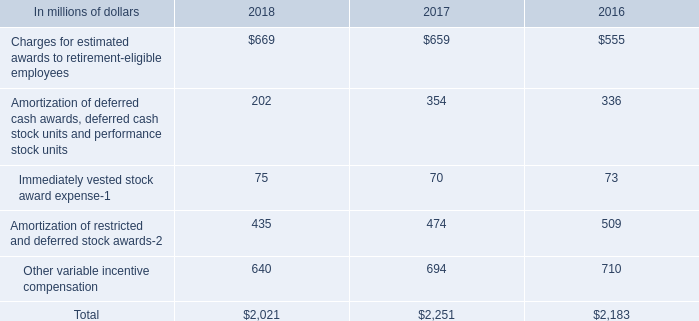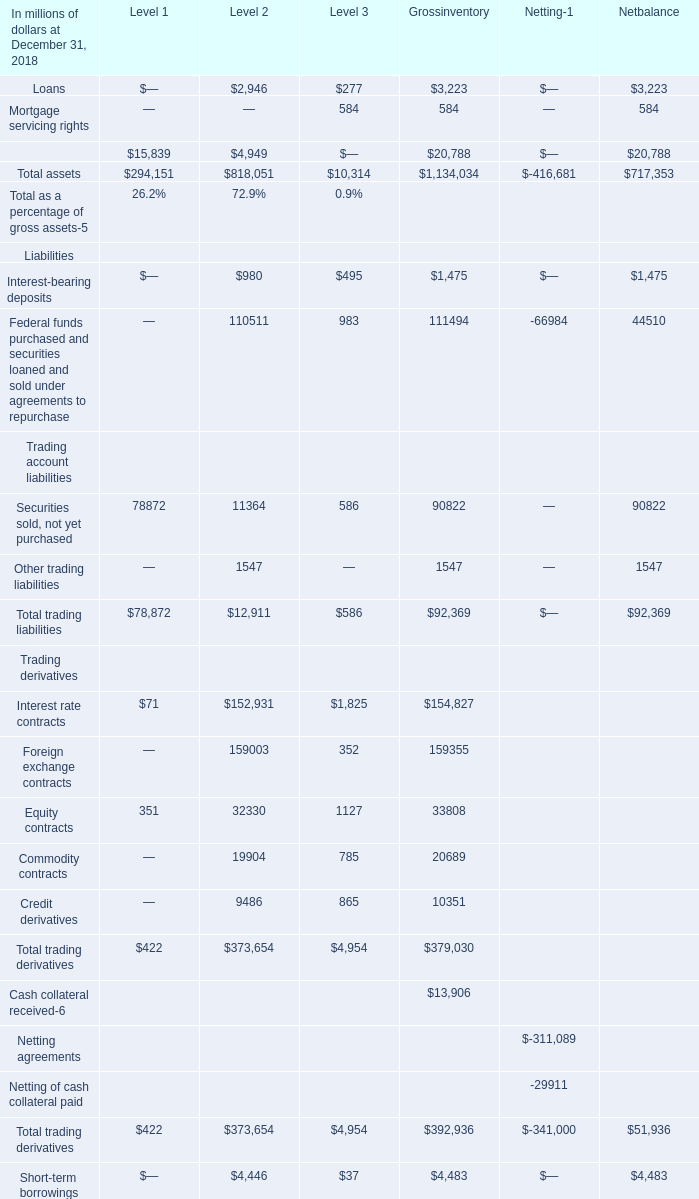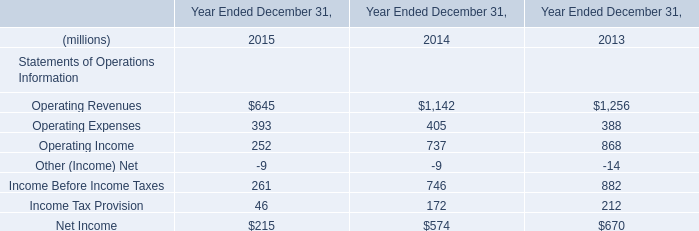what was the percentage change in the total incentive compensation from 2017 to 2018 
Computations: ((2021 - 2251) / 2251)
Answer: -0.10218. 